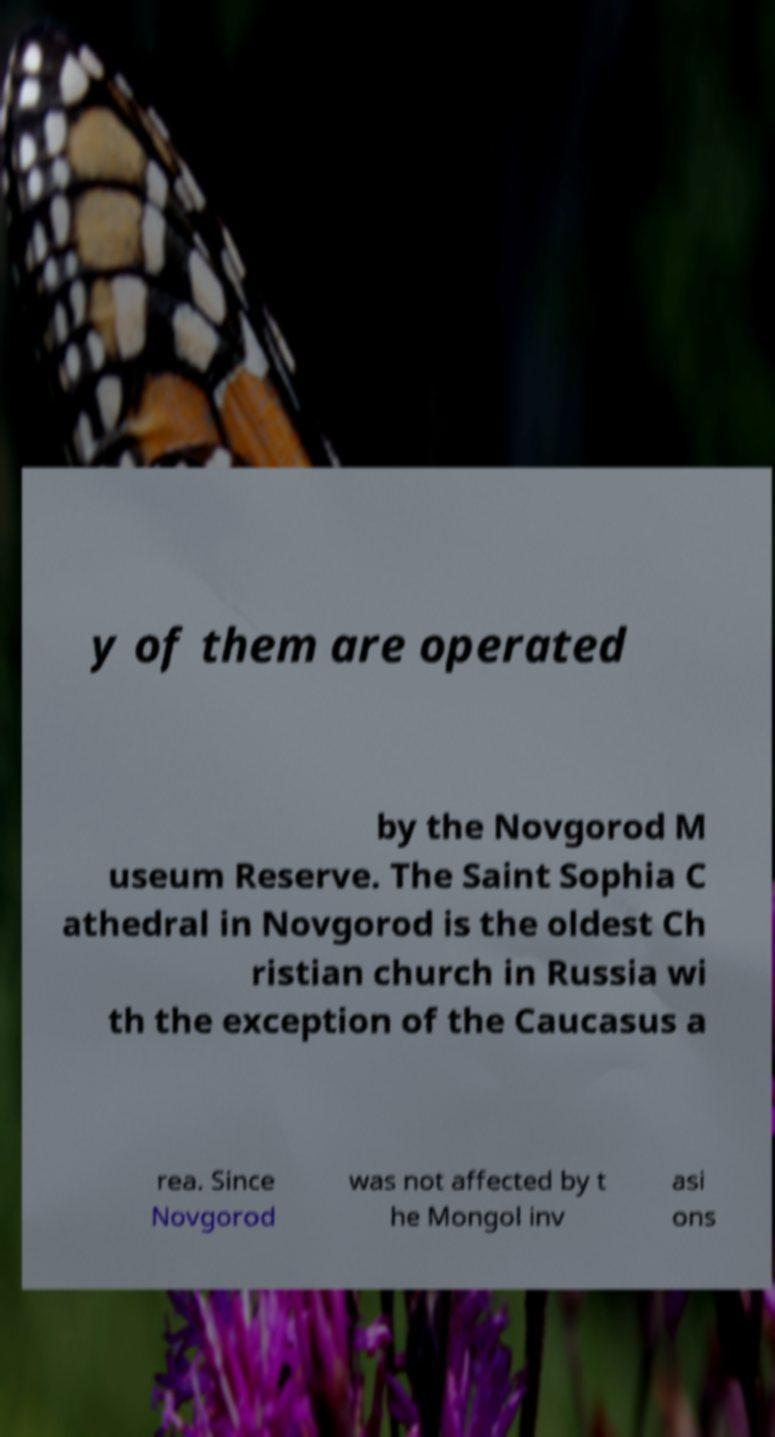I need the written content from this picture converted into text. Can you do that? y of them are operated by the Novgorod M useum Reserve. The Saint Sophia C athedral in Novgorod is the oldest Ch ristian church in Russia wi th the exception of the Caucasus a rea. Since Novgorod was not affected by t he Mongol inv asi ons 